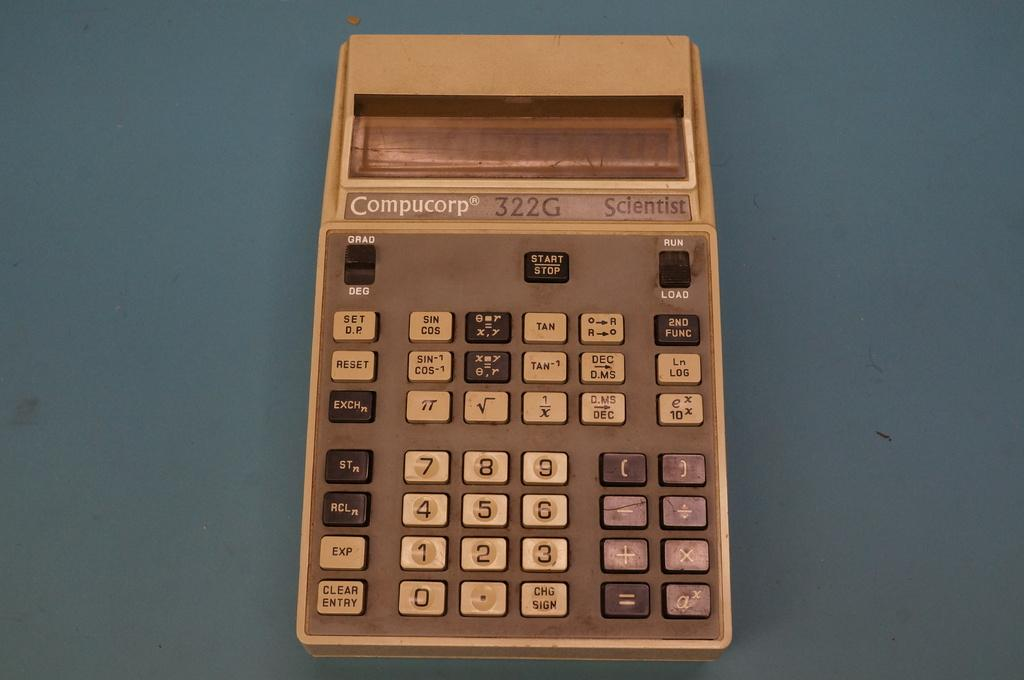What type of device is shown in the image? The object is a calculator. What are the main features of the calculator? The calculator has buttons and a display. Where is the calculator located in the image? The calculator is placed on a table. What type of breakfast is the girl eating next to the calculator in the image? There is no girl or breakfast present in the image; it only features a calculator on a table. 